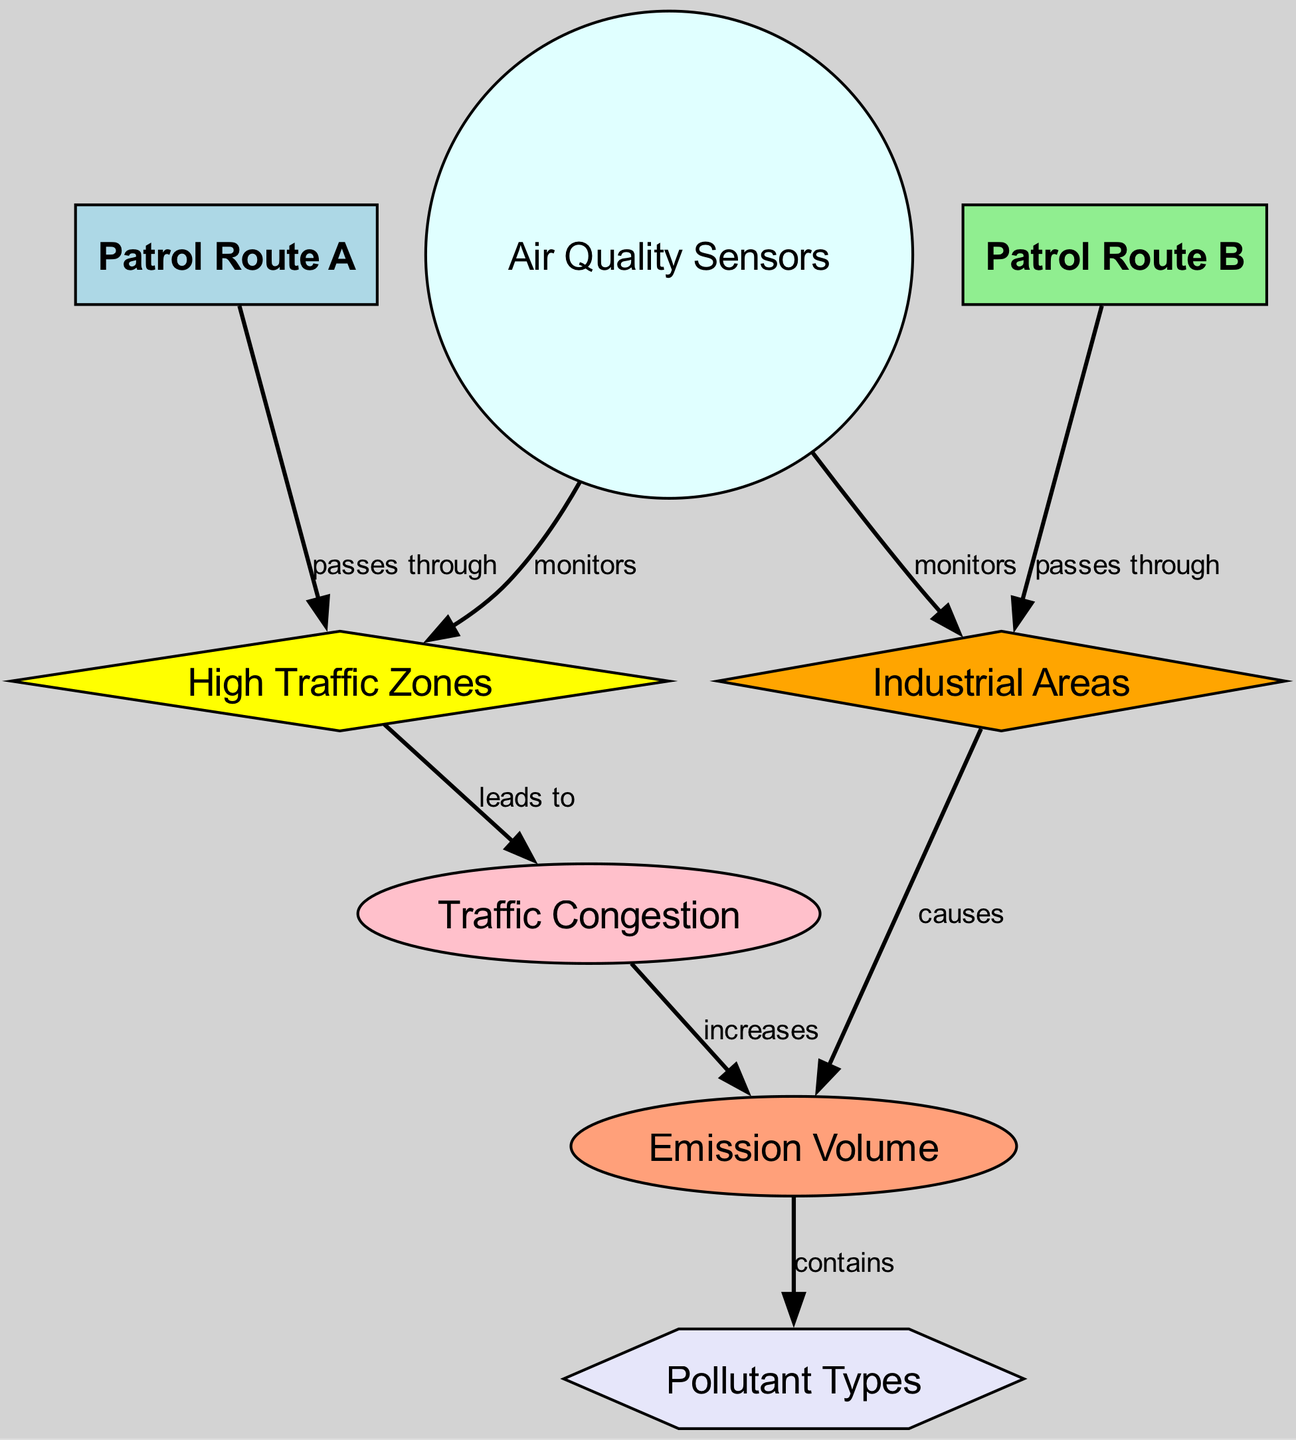What patrol route passes through high traffic zones? The diagram shows an edge between Patrol Route A and High Traffic Zones marked as "passes through." Therefore, Patrol Route A is the route that includes this area.
Answer: Patrol Route A What causes emission volume in industrial areas? The diagram indicates a relationship where Industrial Areas "causes" Emission Volume. This implies that activities in Industrial Areas lead to the emission of pollutants.
Answer: Industrial Areas How many air quality sensors are monitoring the patrol routes? There are two edges leading from Air Quality Sensors to both High Traffic Zones and Industrial Areas, indicating that there are two areas being monitored.
Answer: 2 Which aspect leads to increased emission volume? The diagram shows that Traffic Congestion "increases" Emission Volume, meaning that as traffic congestion rises, emission levels will also rise due to idling and slow-moving vehicles producing more pollutants.
Answer: Traffic Congestion What type of pollutants are present due to emission volume? The diagram states that Emission Volume "contains" Pollutant Types, suggesting that various pollutants are emitted as a result of emissions that occur in the patrol routes affected by traffic and industrial activity.
Answer: Pollutant Types Which patrol route passes through industrial areas? The diagram identifies that Patrol Route B "passes through" Industrial Areas, illustrating that Patrol Route B includes segments that are industrially active.
Answer: Patrol Route B What is the relationship between high traffic zones and traffic congestion? The diagram explicitly states that High Traffic Zones "leads to" Traffic Congestion, indicating that areas of heavy traffic create situations where congestion is likely to occur.
Answer: leads to Which type of areas do air quality sensors monitor? According to the diagram, Air Quality Sensors "monitors" both High Traffic Zones and Industrial Areas, indicating these two types of areas are continuously checked for air quality.
Answer: High Traffic Zones and Industrial Areas 